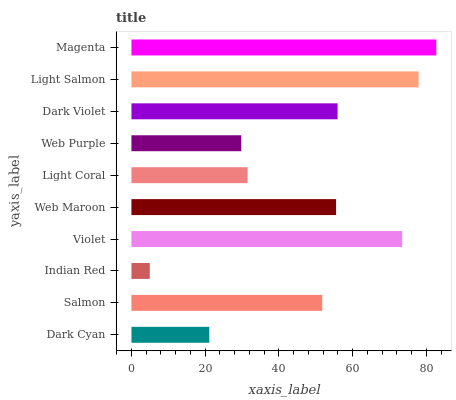Is Indian Red the minimum?
Answer yes or no. Yes. Is Magenta the maximum?
Answer yes or no. Yes. Is Salmon the minimum?
Answer yes or no. No. Is Salmon the maximum?
Answer yes or no. No. Is Salmon greater than Dark Cyan?
Answer yes or no. Yes. Is Dark Cyan less than Salmon?
Answer yes or no. Yes. Is Dark Cyan greater than Salmon?
Answer yes or no. No. Is Salmon less than Dark Cyan?
Answer yes or no. No. Is Web Maroon the high median?
Answer yes or no. Yes. Is Salmon the low median?
Answer yes or no. Yes. Is Magenta the high median?
Answer yes or no. No. Is Indian Red the low median?
Answer yes or no. No. 